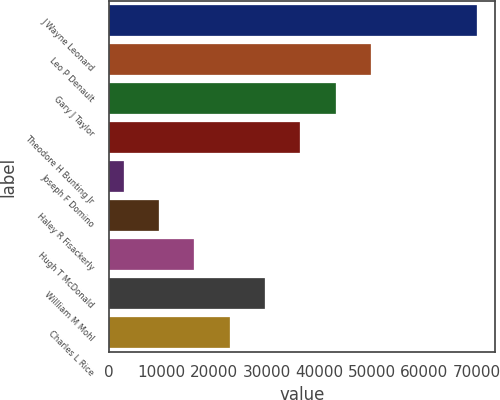Convert chart to OTSL. <chart><loc_0><loc_0><loc_500><loc_500><bar_chart><fcel>J Wayne Leonard<fcel>Leo P Denault<fcel>Gary J Taylor<fcel>Theodore H Bunting Jr<fcel>Joseph F Domino<fcel>Haley R Fisackerly<fcel>Hugh T McDonald<fcel>Willliam M Mohl<fcel>Charles L Rice<nl><fcel>70000<fcel>49870<fcel>43160<fcel>36450<fcel>2900<fcel>9610<fcel>16320<fcel>29740<fcel>23030<nl></chart> 